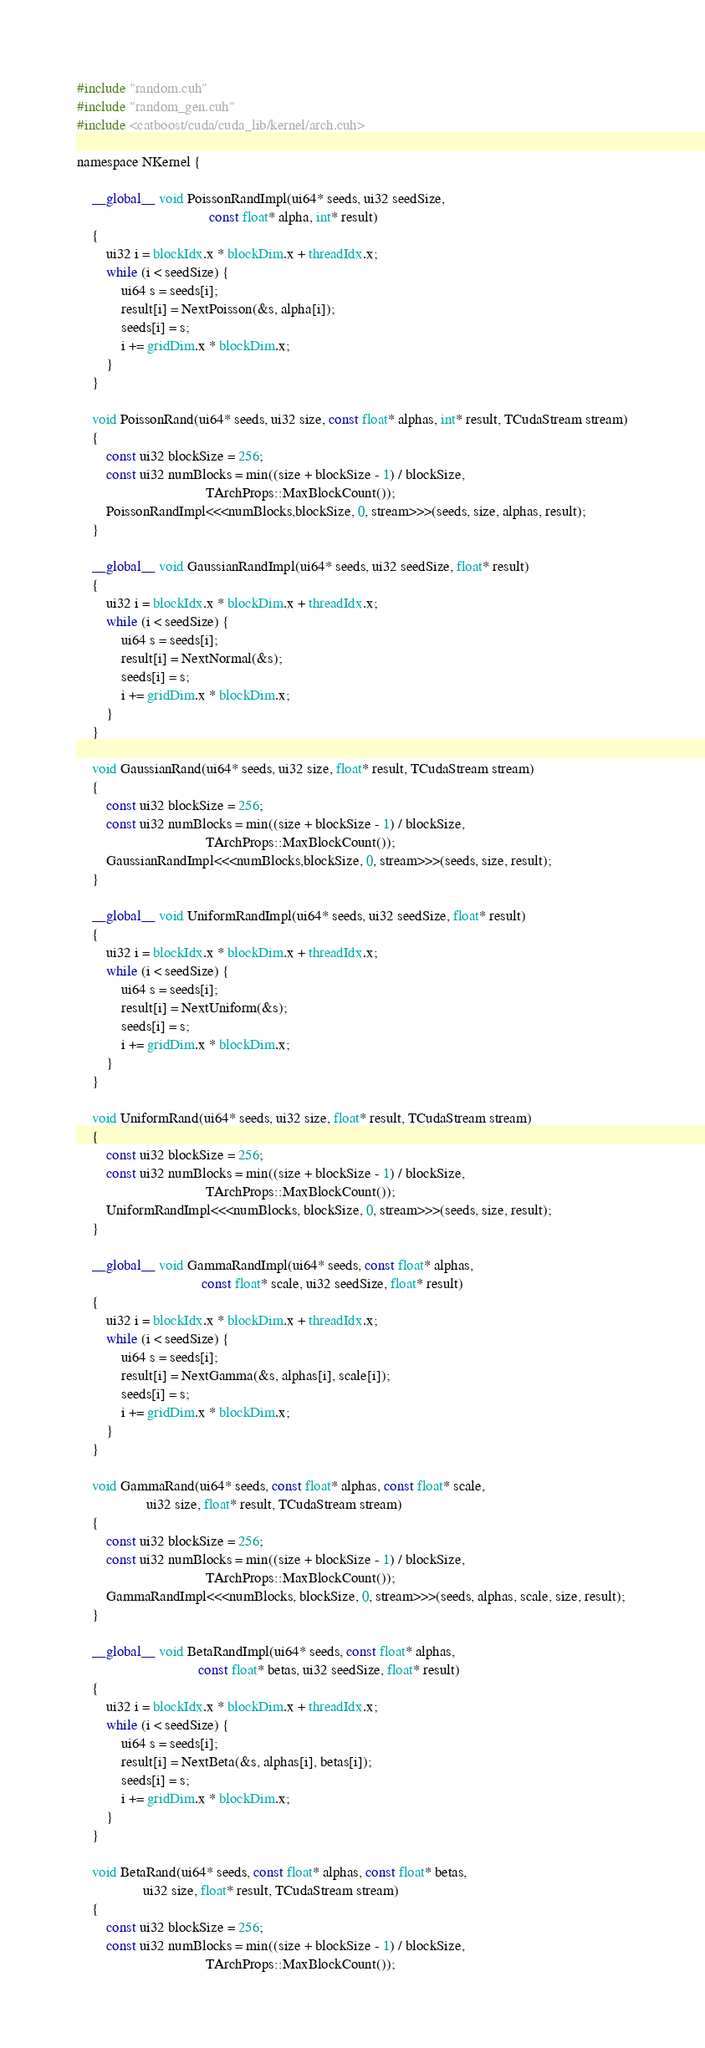Convert code to text. <code><loc_0><loc_0><loc_500><loc_500><_Cuda_>#include "random.cuh"
#include "random_gen.cuh"
#include <catboost/cuda/cuda_lib/kernel/arch.cuh>

namespace NKernel {

    __global__ void PoissonRandImpl(ui64* seeds, ui32 seedSize,
                                    const float* alpha, int* result)
    {
        ui32 i = blockIdx.x * blockDim.x + threadIdx.x;
        while (i < seedSize) {
            ui64 s = seeds[i];
            result[i] = NextPoisson(&s, alpha[i]);
            seeds[i] = s;
            i += gridDim.x * blockDim.x;
        }
    }

    void PoissonRand(ui64* seeds, ui32 size, const float* alphas, int* result, TCudaStream stream)
    {
        const ui32 blockSize = 256;
        const ui32 numBlocks = min((size + blockSize - 1) / blockSize,
                                   TArchProps::MaxBlockCount());
        PoissonRandImpl<<<numBlocks,blockSize, 0, stream>>>(seeds, size, alphas, result);
    }

    __global__ void GaussianRandImpl(ui64* seeds, ui32 seedSize, float* result)
    {
        ui32 i = blockIdx.x * blockDim.x + threadIdx.x;
        while (i < seedSize) {
            ui64 s = seeds[i];
            result[i] = NextNormal(&s);
            seeds[i] = s;
            i += gridDim.x * blockDim.x;
        }
    }

    void GaussianRand(ui64* seeds, ui32 size, float* result, TCudaStream stream)
    {
        const ui32 blockSize = 256;
        const ui32 numBlocks = min((size + blockSize - 1) / blockSize,
                                   TArchProps::MaxBlockCount());
        GaussianRandImpl<<<numBlocks,blockSize, 0, stream>>>(seeds, size, result);
    }

    __global__ void UniformRandImpl(ui64* seeds, ui32 seedSize, float* result)
    {
        ui32 i = blockIdx.x * blockDim.x + threadIdx.x;
        while (i < seedSize) {
            ui64 s = seeds[i];
            result[i] = NextUniform(&s);
            seeds[i] = s;
            i += gridDim.x * blockDim.x;
        }
    }

    void UniformRand(ui64* seeds, ui32 size, float* result, TCudaStream stream)
    {
        const ui32 blockSize = 256;
        const ui32 numBlocks = min((size + blockSize - 1) / blockSize,
                                   TArchProps::MaxBlockCount());
        UniformRandImpl<<<numBlocks, blockSize, 0, stream>>>(seeds, size, result);
    }

    __global__ void GammaRandImpl(ui64* seeds, const float* alphas,
                                  const float* scale, ui32 seedSize, float* result)
    {
        ui32 i = blockIdx.x * blockDim.x + threadIdx.x;
        while (i < seedSize) {
            ui64 s = seeds[i];
            result[i] = NextGamma(&s, alphas[i], scale[i]);
            seeds[i] = s;
            i += gridDim.x * blockDim.x;
        }
    }

    void GammaRand(ui64* seeds, const float* alphas, const float* scale,
                   ui32 size, float* result, TCudaStream stream)
    {
        const ui32 blockSize = 256;
        const ui32 numBlocks = min((size + blockSize - 1) / blockSize,
                                   TArchProps::MaxBlockCount());
        GammaRandImpl<<<numBlocks, blockSize, 0, stream>>>(seeds, alphas, scale, size, result);
    }

    __global__ void BetaRandImpl(ui64* seeds, const float* alphas,
                                 const float* betas, ui32 seedSize, float* result)
    {
        ui32 i = blockIdx.x * blockDim.x + threadIdx.x;
        while (i < seedSize) {
            ui64 s = seeds[i];
            result[i] = NextBeta(&s, alphas[i], betas[i]);
            seeds[i] = s;
            i += gridDim.x * blockDim.x;
        }
    }

    void BetaRand(ui64* seeds, const float* alphas, const float* betas,
                  ui32 size, float* result, TCudaStream stream)
    {
        const ui32 blockSize = 256;
        const ui32 numBlocks = min((size + blockSize - 1) / blockSize,
                                   TArchProps::MaxBlockCount());</code> 